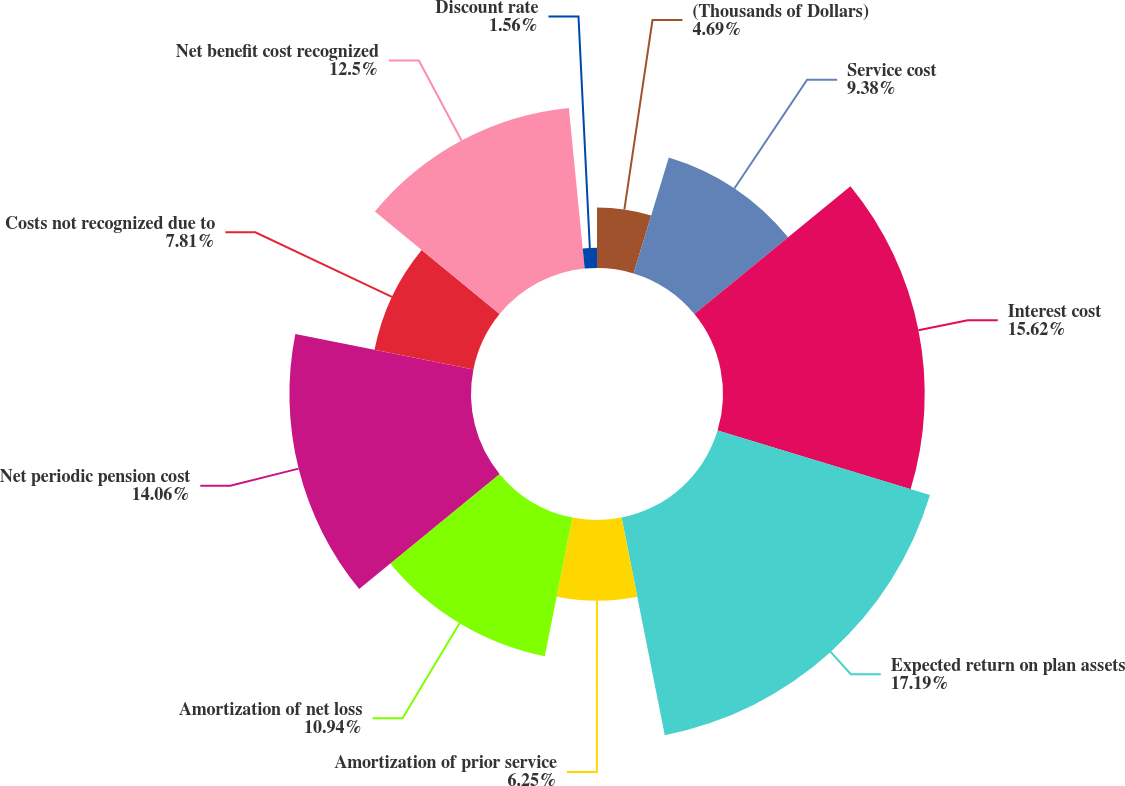Convert chart to OTSL. <chart><loc_0><loc_0><loc_500><loc_500><pie_chart><fcel>(Thousands of Dollars)<fcel>Service cost<fcel>Interest cost<fcel>Expected return on plan assets<fcel>Amortization of prior service<fcel>Amortization of net loss<fcel>Net periodic pension cost<fcel>Costs not recognized due to<fcel>Net benefit cost recognized<fcel>Discount rate<nl><fcel>4.69%<fcel>9.38%<fcel>15.62%<fcel>17.19%<fcel>6.25%<fcel>10.94%<fcel>14.06%<fcel>7.81%<fcel>12.5%<fcel>1.56%<nl></chart> 